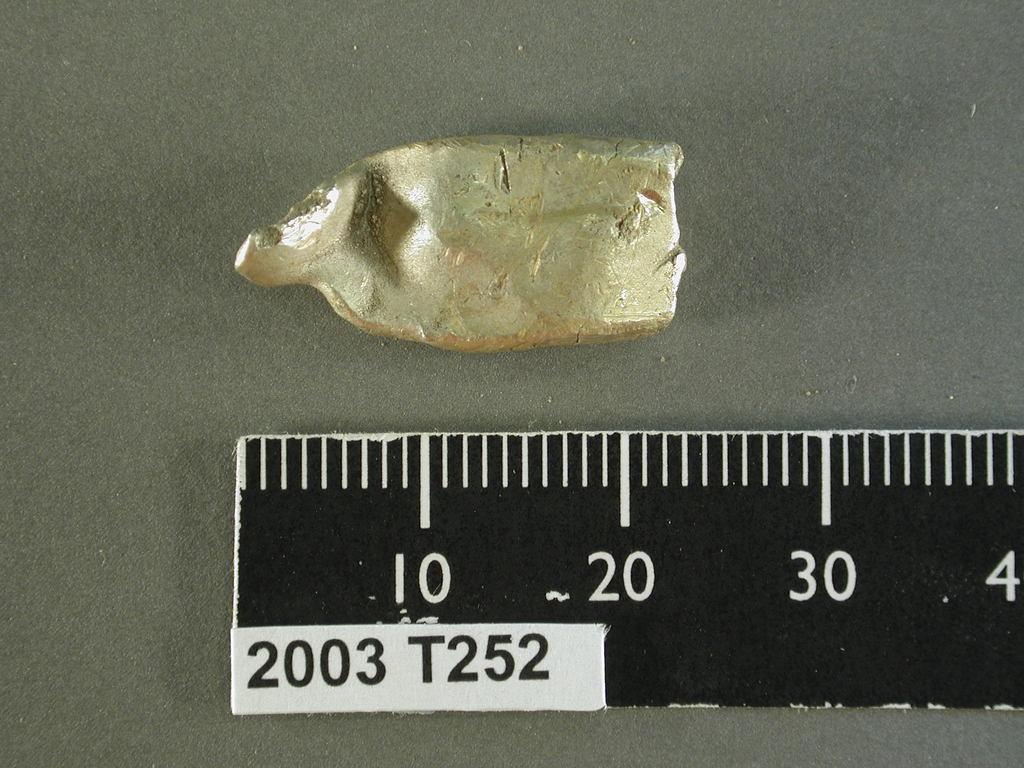What year is shown on the sticker?
Your answer should be compact. 2003. How large is this item?
Your response must be concise. 20. 